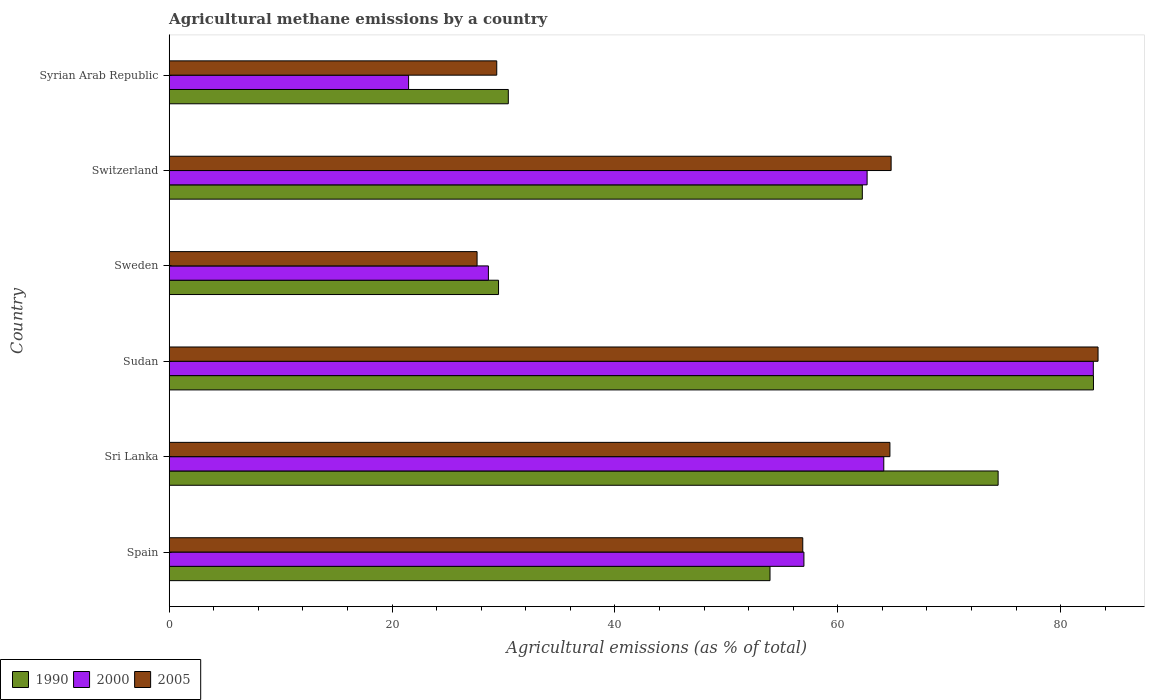How many different coloured bars are there?
Ensure brevity in your answer.  3. How many groups of bars are there?
Provide a short and direct response. 6. Are the number of bars on each tick of the Y-axis equal?
Offer a terse response. Yes. How many bars are there on the 3rd tick from the bottom?
Your answer should be compact. 3. What is the label of the 1st group of bars from the top?
Your response must be concise. Syrian Arab Republic. What is the amount of agricultural methane emitted in 2000 in Sweden?
Keep it short and to the point. 28.65. Across all countries, what is the maximum amount of agricultural methane emitted in 1990?
Your answer should be very brief. 82.95. Across all countries, what is the minimum amount of agricultural methane emitted in 1990?
Your answer should be very brief. 29.55. In which country was the amount of agricultural methane emitted in 2005 maximum?
Provide a short and direct response. Sudan. In which country was the amount of agricultural methane emitted in 2000 minimum?
Offer a very short reply. Syrian Arab Republic. What is the total amount of agricultural methane emitted in 1990 in the graph?
Your answer should be compact. 333.45. What is the difference between the amount of agricultural methane emitted in 2005 in Switzerland and that in Syrian Arab Republic?
Your answer should be compact. 35.39. What is the difference between the amount of agricultural methane emitted in 1990 in Sri Lanka and the amount of agricultural methane emitted in 2005 in Sudan?
Your answer should be compact. -8.97. What is the average amount of agricultural methane emitted in 1990 per country?
Offer a very short reply. 55.57. What is the difference between the amount of agricultural methane emitted in 2005 and amount of agricultural methane emitted in 2000 in Sweden?
Your answer should be very brief. -1.02. In how many countries, is the amount of agricultural methane emitted in 2000 greater than 16 %?
Your answer should be compact. 6. What is the ratio of the amount of agricultural methane emitted in 2000 in Spain to that in Sudan?
Offer a terse response. 0.69. Is the difference between the amount of agricultural methane emitted in 2005 in Sudan and Sweden greater than the difference between the amount of agricultural methane emitted in 2000 in Sudan and Sweden?
Your answer should be compact. Yes. What is the difference between the highest and the second highest amount of agricultural methane emitted in 1990?
Your answer should be compact. 8.56. What is the difference between the highest and the lowest amount of agricultural methane emitted in 2005?
Make the answer very short. 55.73. In how many countries, is the amount of agricultural methane emitted in 2000 greater than the average amount of agricultural methane emitted in 2000 taken over all countries?
Offer a very short reply. 4. Is the sum of the amount of agricultural methane emitted in 2000 in Switzerland and Syrian Arab Republic greater than the maximum amount of agricultural methane emitted in 2005 across all countries?
Provide a short and direct response. Yes. What does the 3rd bar from the top in Sudan represents?
Make the answer very short. 1990. What does the 1st bar from the bottom in Switzerland represents?
Provide a short and direct response. 1990. What is the difference between two consecutive major ticks on the X-axis?
Your answer should be very brief. 20. Does the graph contain grids?
Offer a terse response. No. How many legend labels are there?
Your response must be concise. 3. How are the legend labels stacked?
Your response must be concise. Horizontal. What is the title of the graph?
Make the answer very short. Agricultural methane emissions by a country. Does "1976" appear as one of the legend labels in the graph?
Offer a terse response. No. What is the label or title of the X-axis?
Make the answer very short. Agricultural emissions (as % of total). What is the label or title of the Y-axis?
Ensure brevity in your answer.  Country. What is the Agricultural emissions (as % of total) of 1990 in Spain?
Your answer should be very brief. 53.92. What is the Agricultural emissions (as % of total) in 2000 in Spain?
Give a very brief answer. 56.96. What is the Agricultural emissions (as % of total) of 2005 in Spain?
Offer a very short reply. 56.86. What is the Agricultural emissions (as % of total) of 1990 in Sri Lanka?
Offer a very short reply. 74.39. What is the Agricultural emissions (as % of total) of 2000 in Sri Lanka?
Your response must be concise. 64.13. What is the Agricultural emissions (as % of total) in 2005 in Sri Lanka?
Make the answer very short. 64.68. What is the Agricultural emissions (as % of total) in 1990 in Sudan?
Make the answer very short. 82.95. What is the Agricultural emissions (as % of total) in 2000 in Sudan?
Provide a short and direct response. 82.93. What is the Agricultural emissions (as % of total) in 2005 in Sudan?
Offer a terse response. 83.36. What is the Agricultural emissions (as % of total) of 1990 in Sweden?
Offer a very short reply. 29.55. What is the Agricultural emissions (as % of total) of 2000 in Sweden?
Provide a short and direct response. 28.65. What is the Agricultural emissions (as % of total) of 2005 in Sweden?
Provide a short and direct response. 27.63. What is the Agricultural emissions (as % of total) of 1990 in Switzerland?
Your answer should be compact. 62.2. What is the Agricultural emissions (as % of total) of 2000 in Switzerland?
Your answer should be very brief. 62.63. What is the Agricultural emissions (as % of total) of 2005 in Switzerland?
Your response must be concise. 64.79. What is the Agricultural emissions (as % of total) of 1990 in Syrian Arab Republic?
Keep it short and to the point. 30.43. What is the Agricultural emissions (as % of total) of 2000 in Syrian Arab Republic?
Give a very brief answer. 21.48. What is the Agricultural emissions (as % of total) in 2005 in Syrian Arab Republic?
Provide a succinct answer. 29.39. Across all countries, what is the maximum Agricultural emissions (as % of total) in 1990?
Make the answer very short. 82.95. Across all countries, what is the maximum Agricultural emissions (as % of total) of 2000?
Your answer should be compact. 82.93. Across all countries, what is the maximum Agricultural emissions (as % of total) in 2005?
Offer a very short reply. 83.36. Across all countries, what is the minimum Agricultural emissions (as % of total) in 1990?
Ensure brevity in your answer.  29.55. Across all countries, what is the minimum Agricultural emissions (as % of total) in 2000?
Provide a succinct answer. 21.48. Across all countries, what is the minimum Agricultural emissions (as % of total) in 2005?
Your answer should be compact. 27.63. What is the total Agricultural emissions (as % of total) in 1990 in the graph?
Provide a short and direct response. 333.45. What is the total Agricultural emissions (as % of total) of 2000 in the graph?
Your answer should be compact. 316.79. What is the total Agricultural emissions (as % of total) of 2005 in the graph?
Keep it short and to the point. 326.71. What is the difference between the Agricultural emissions (as % of total) in 1990 in Spain and that in Sri Lanka?
Make the answer very short. -20.47. What is the difference between the Agricultural emissions (as % of total) of 2000 in Spain and that in Sri Lanka?
Keep it short and to the point. -7.17. What is the difference between the Agricultural emissions (as % of total) of 2005 in Spain and that in Sri Lanka?
Offer a terse response. -7.82. What is the difference between the Agricultural emissions (as % of total) in 1990 in Spain and that in Sudan?
Give a very brief answer. -29.03. What is the difference between the Agricultural emissions (as % of total) in 2000 in Spain and that in Sudan?
Ensure brevity in your answer.  -25.97. What is the difference between the Agricultural emissions (as % of total) of 2005 in Spain and that in Sudan?
Ensure brevity in your answer.  -26.5. What is the difference between the Agricultural emissions (as % of total) of 1990 in Spain and that in Sweden?
Provide a succinct answer. 24.36. What is the difference between the Agricultural emissions (as % of total) in 2000 in Spain and that in Sweden?
Provide a succinct answer. 28.32. What is the difference between the Agricultural emissions (as % of total) of 2005 in Spain and that in Sweden?
Offer a very short reply. 29.23. What is the difference between the Agricultural emissions (as % of total) of 1990 in Spain and that in Switzerland?
Your answer should be compact. -8.29. What is the difference between the Agricultural emissions (as % of total) of 2000 in Spain and that in Switzerland?
Offer a very short reply. -5.67. What is the difference between the Agricultural emissions (as % of total) of 2005 in Spain and that in Switzerland?
Keep it short and to the point. -7.93. What is the difference between the Agricultural emissions (as % of total) of 1990 in Spain and that in Syrian Arab Republic?
Your answer should be compact. 23.49. What is the difference between the Agricultural emissions (as % of total) in 2000 in Spain and that in Syrian Arab Republic?
Offer a very short reply. 35.48. What is the difference between the Agricultural emissions (as % of total) of 2005 in Spain and that in Syrian Arab Republic?
Offer a very short reply. 27.46. What is the difference between the Agricultural emissions (as % of total) of 1990 in Sri Lanka and that in Sudan?
Ensure brevity in your answer.  -8.56. What is the difference between the Agricultural emissions (as % of total) of 2000 in Sri Lanka and that in Sudan?
Provide a succinct answer. -18.8. What is the difference between the Agricultural emissions (as % of total) of 2005 in Sri Lanka and that in Sudan?
Keep it short and to the point. -18.68. What is the difference between the Agricultural emissions (as % of total) of 1990 in Sri Lanka and that in Sweden?
Ensure brevity in your answer.  44.84. What is the difference between the Agricultural emissions (as % of total) in 2000 in Sri Lanka and that in Sweden?
Your response must be concise. 35.48. What is the difference between the Agricultural emissions (as % of total) in 2005 in Sri Lanka and that in Sweden?
Provide a succinct answer. 37.05. What is the difference between the Agricultural emissions (as % of total) of 1990 in Sri Lanka and that in Switzerland?
Provide a short and direct response. 12.19. What is the difference between the Agricultural emissions (as % of total) of 2000 in Sri Lanka and that in Switzerland?
Make the answer very short. 1.5. What is the difference between the Agricultural emissions (as % of total) in 2005 in Sri Lanka and that in Switzerland?
Provide a succinct answer. -0.11. What is the difference between the Agricultural emissions (as % of total) of 1990 in Sri Lanka and that in Syrian Arab Republic?
Provide a short and direct response. 43.96. What is the difference between the Agricultural emissions (as % of total) in 2000 in Sri Lanka and that in Syrian Arab Republic?
Your answer should be compact. 42.65. What is the difference between the Agricultural emissions (as % of total) in 2005 in Sri Lanka and that in Syrian Arab Republic?
Provide a short and direct response. 35.28. What is the difference between the Agricultural emissions (as % of total) in 1990 in Sudan and that in Sweden?
Give a very brief answer. 53.39. What is the difference between the Agricultural emissions (as % of total) in 2000 in Sudan and that in Sweden?
Give a very brief answer. 54.29. What is the difference between the Agricultural emissions (as % of total) of 2005 in Sudan and that in Sweden?
Offer a very short reply. 55.73. What is the difference between the Agricultural emissions (as % of total) in 1990 in Sudan and that in Switzerland?
Provide a succinct answer. 20.74. What is the difference between the Agricultural emissions (as % of total) of 2000 in Sudan and that in Switzerland?
Offer a very short reply. 20.3. What is the difference between the Agricultural emissions (as % of total) in 2005 in Sudan and that in Switzerland?
Your response must be concise. 18.57. What is the difference between the Agricultural emissions (as % of total) of 1990 in Sudan and that in Syrian Arab Republic?
Your response must be concise. 52.51. What is the difference between the Agricultural emissions (as % of total) in 2000 in Sudan and that in Syrian Arab Republic?
Provide a succinct answer. 61.45. What is the difference between the Agricultural emissions (as % of total) of 2005 in Sudan and that in Syrian Arab Republic?
Provide a succinct answer. 53.96. What is the difference between the Agricultural emissions (as % of total) of 1990 in Sweden and that in Switzerland?
Offer a terse response. -32.65. What is the difference between the Agricultural emissions (as % of total) in 2000 in Sweden and that in Switzerland?
Give a very brief answer. -33.99. What is the difference between the Agricultural emissions (as % of total) in 2005 in Sweden and that in Switzerland?
Your answer should be compact. -37.16. What is the difference between the Agricultural emissions (as % of total) in 1990 in Sweden and that in Syrian Arab Republic?
Your response must be concise. -0.88. What is the difference between the Agricultural emissions (as % of total) of 2000 in Sweden and that in Syrian Arab Republic?
Offer a terse response. 7.16. What is the difference between the Agricultural emissions (as % of total) of 2005 in Sweden and that in Syrian Arab Republic?
Your answer should be compact. -1.77. What is the difference between the Agricultural emissions (as % of total) in 1990 in Switzerland and that in Syrian Arab Republic?
Your answer should be compact. 31.77. What is the difference between the Agricultural emissions (as % of total) of 2000 in Switzerland and that in Syrian Arab Republic?
Offer a terse response. 41.15. What is the difference between the Agricultural emissions (as % of total) of 2005 in Switzerland and that in Syrian Arab Republic?
Offer a terse response. 35.39. What is the difference between the Agricultural emissions (as % of total) of 1990 in Spain and the Agricultural emissions (as % of total) of 2000 in Sri Lanka?
Your response must be concise. -10.21. What is the difference between the Agricultural emissions (as % of total) in 1990 in Spain and the Agricultural emissions (as % of total) in 2005 in Sri Lanka?
Offer a very short reply. -10.76. What is the difference between the Agricultural emissions (as % of total) of 2000 in Spain and the Agricultural emissions (as % of total) of 2005 in Sri Lanka?
Provide a succinct answer. -7.72. What is the difference between the Agricultural emissions (as % of total) of 1990 in Spain and the Agricultural emissions (as % of total) of 2000 in Sudan?
Keep it short and to the point. -29.01. What is the difference between the Agricultural emissions (as % of total) in 1990 in Spain and the Agricultural emissions (as % of total) in 2005 in Sudan?
Keep it short and to the point. -29.44. What is the difference between the Agricultural emissions (as % of total) of 2000 in Spain and the Agricultural emissions (as % of total) of 2005 in Sudan?
Ensure brevity in your answer.  -26.4. What is the difference between the Agricultural emissions (as % of total) of 1990 in Spain and the Agricultural emissions (as % of total) of 2000 in Sweden?
Your response must be concise. 25.27. What is the difference between the Agricultural emissions (as % of total) of 1990 in Spain and the Agricultural emissions (as % of total) of 2005 in Sweden?
Offer a terse response. 26.29. What is the difference between the Agricultural emissions (as % of total) in 2000 in Spain and the Agricultural emissions (as % of total) in 2005 in Sweden?
Offer a very short reply. 29.33. What is the difference between the Agricultural emissions (as % of total) of 1990 in Spain and the Agricultural emissions (as % of total) of 2000 in Switzerland?
Your answer should be very brief. -8.71. What is the difference between the Agricultural emissions (as % of total) of 1990 in Spain and the Agricultural emissions (as % of total) of 2005 in Switzerland?
Offer a terse response. -10.87. What is the difference between the Agricultural emissions (as % of total) in 2000 in Spain and the Agricultural emissions (as % of total) in 2005 in Switzerland?
Your response must be concise. -7.83. What is the difference between the Agricultural emissions (as % of total) in 1990 in Spain and the Agricultural emissions (as % of total) in 2000 in Syrian Arab Republic?
Give a very brief answer. 32.44. What is the difference between the Agricultural emissions (as % of total) in 1990 in Spain and the Agricultural emissions (as % of total) in 2005 in Syrian Arab Republic?
Your response must be concise. 24.52. What is the difference between the Agricultural emissions (as % of total) in 2000 in Spain and the Agricultural emissions (as % of total) in 2005 in Syrian Arab Republic?
Your answer should be very brief. 27.57. What is the difference between the Agricultural emissions (as % of total) of 1990 in Sri Lanka and the Agricultural emissions (as % of total) of 2000 in Sudan?
Give a very brief answer. -8.54. What is the difference between the Agricultural emissions (as % of total) in 1990 in Sri Lanka and the Agricultural emissions (as % of total) in 2005 in Sudan?
Your response must be concise. -8.97. What is the difference between the Agricultural emissions (as % of total) of 2000 in Sri Lanka and the Agricultural emissions (as % of total) of 2005 in Sudan?
Offer a very short reply. -19.23. What is the difference between the Agricultural emissions (as % of total) in 1990 in Sri Lanka and the Agricultural emissions (as % of total) in 2000 in Sweden?
Your answer should be compact. 45.74. What is the difference between the Agricultural emissions (as % of total) of 1990 in Sri Lanka and the Agricultural emissions (as % of total) of 2005 in Sweden?
Offer a terse response. 46.76. What is the difference between the Agricultural emissions (as % of total) in 2000 in Sri Lanka and the Agricultural emissions (as % of total) in 2005 in Sweden?
Offer a very short reply. 36.5. What is the difference between the Agricultural emissions (as % of total) in 1990 in Sri Lanka and the Agricultural emissions (as % of total) in 2000 in Switzerland?
Keep it short and to the point. 11.76. What is the difference between the Agricultural emissions (as % of total) of 1990 in Sri Lanka and the Agricultural emissions (as % of total) of 2005 in Switzerland?
Make the answer very short. 9.6. What is the difference between the Agricultural emissions (as % of total) in 2000 in Sri Lanka and the Agricultural emissions (as % of total) in 2005 in Switzerland?
Keep it short and to the point. -0.66. What is the difference between the Agricultural emissions (as % of total) in 1990 in Sri Lanka and the Agricultural emissions (as % of total) in 2000 in Syrian Arab Republic?
Ensure brevity in your answer.  52.91. What is the difference between the Agricultural emissions (as % of total) in 1990 in Sri Lanka and the Agricultural emissions (as % of total) in 2005 in Syrian Arab Republic?
Provide a short and direct response. 45. What is the difference between the Agricultural emissions (as % of total) in 2000 in Sri Lanka and the Agricultural emissions (as % of total) in 2005 in Syrian Arab Republic?
Your answer should be compact. 34.73. What is the difference between the Agricultural emissions (as % of total) in 1990 in Sudan and the Agricultural emissions (as % of total) in 2000 in Sweden?
Offer a terse response. 54.3. What is the difference between the Agricultural emissions (as % of total) of 1990 in Sudan and the Agricultural emissions (as % of total) of 2005 in Sweden?
Make the answer very short. 55.32. What is the difference between the Agricultural emissions (as % of total) in 2000 in Sudan and the Agricultural emissions (as % of total) in 2005 in Sweden?
Offer a terse response. 55.3. What is the difference between the Agricultural emissions (as % of total) in 1990 in Sudan and the Agricultural emissions (as % of total) in 2000 in Switzerland?
Make the answer very short. 20.31. What is the difference between the Agricultural emissions (as % of total) of 1990 in Sudan and the Agricultural emissions (as % of total) of 2005 in Switzerland?
Ensure brevity in your answer.  18.16. What is the difference between the Agricultural emissions (as % of total) in 2000 in Sudan and the Agricultural emissions (as % of total) in 2005 in Switzerland?
Make the answer very short. 18.14. What is the difference between the Agricultural emissions (as % of total) of 1990 in Sudan and the Agricultural emissions (as % of total) of 2000 in Syrian Arab Republic?
Offer a terse response. 61.46. What is the difference between the Agricultural emissions (as % of total) in 1990 in Sudan and the Agricultural emissions (as % of total) in 2005 in Syrian Arab Republic?
Offer a very short reply. 53.55. What is the difference between the Agricultural emissions (as % of total) of 2000 in Sudan and the Agricultural emissions (as % of total) of 2005 in Syrian Arab Republic?
Your answer should be very brief. 53.54. What is the difference between the Agricultural emissions (as % of total) in 1990 in Sweden and the Agricultural emissions (as % of total) in 2000 in Switzerland?
Keep it short and to the point. -33.08. What is the difference between the Agricultural emissions (as % of total) in 1990 in Sweden and the Agricultural emissions (as % of total) in 2005 in Switzerland?
Offer a very short reply. -35.23. What is the difference between the Agricultural emissions (as % of total) of 2000 in Sweden and the Agricultural emissions (as % of total) of 2005 in Switzerland?
Offer a terse response. -36.14. What is the difference between the Agricultural emissions (as % of total) in 1990 in Sweden and the Agricultural emissions (as % of total) in 2000 in Syrian Arab Republic?
Offer a terse response. 8.07. What is the difference between the Agricultural emissions (as % of total) in 1990 in Sweden and the Agricultural emissions (as % of total) in 2005 in Syrian Arab Republic?
Offer a very short reply. 0.16. What is the difference between the Agricultural emissions (as % of total) in 2000 in Sweden and the Agricultural emissions (as % of total) in 2005 in Syrian Arab Republic?
Your response must be concise. -0.75. What is the difference between the Agricultural emissions (as % of total) in 1990 in Switzerland and the Agricultural emissions (as % of total) in 2000 in Syrian Arab Republic?
Make the answer very short. 40.72. What is the difference between the Agricultural emissions (as % of total) of 1990 in Switzerland and the Agricultural emissions (as % of total) of 2005 in Syrian Arab Republic?
Offer a terse response. 32.81. What is the difference between the Agricultural emissions (as % of total) of 2000 in Switzerland and the Agricultural emissions (as % of total) of 2005 in Syrian Arab Republic?
Offer a terse response. 33.24. What is the average Agricultural emissions (as % of total) in 1990 per country?
Keep it short and to the point. 55.57. What is the average Agricultural emissions (as % of total) of 2000 per country?
Your answer should be very brief. 52.8. What is the average Agricultural emissions (as % of total) in 2005 per country?
Offer a terse response. 54.45. What is the difference between the Agricultural emissions (as % of total) of 1990 and Agricultural emissions (as % of total) of 2000 in Spain?
Provide a short and direct response. -3.04. What is the difference between the Agricultural emissions (as % of total) of 1990 and Agricultural emissions (as % of total) of 2005 in Spain?
Offer a terse response. -2.94. What is the difference between the Agricultural emissions (as % of total) in 2000 and Agricultural emissions (as % of total) in 2005 in Spain?
Provide a succinct answer. 0.1. What is the difference between the Agricultural emissions (as % of total) in 1990 and Agricultural emissions (as % of total) in 2000 in Sri Lanka?
Ensure brevity in your answer.  10.26. What is the difference between the Agricultural emissions (as % of total) of 1990 and Agricultural emissions (as % of total) of 2005 in Sri Lanka?
Keep it short and to the point. 9.71. What is the difference between the Agricultural emissions (as % of total) of 2000 and Agricultural emissions (as % of total) of 2005 in Sri Lanka?
Offer a very short reply. -0.55. What is the difference between the Agricultural emissions (as % of total) of 1990 and Agricultural emissions (as % of total) of 2000 in Sudan?
Your response must be concise. 0.01. What is the difference between the Agricultural emissions (as % of total) of 1990 and Agricultural emissions (as % of total) of 2005 in Sudan?
Keep it short and to the point. -0.41. What is the difference between the Agricultural emissions (as % of total) in 2000 and Agricultural emissions (as % of total) in 2005 in Sudan?
Provide a succinct answer. -0.43. What is the difference between the Agricultural emissions (as % of total) in 1990 and Agricultural emissions (as % of total) in 2000 in Sweden?
Keep it short and to the point. 0.91. What is the difference between the Agricultural emissions (as % of total) of 1990 and Agricultural emissions (as % of total) of 2005 in Sweden?
Your answer should be very brief. 1.93. What is the difference between the Agricultural emissions (as % of total) in 2000 and Agricultural emissions (as % of total) in 2005 in Sweden?
Your response must be concise. 1.02. What is the difference between the Agricultural emissions (as % of total) in 1990 and Agricultural emissions (as % of total) in 2000 in Switzerland?
Ensure brevity in your answer.  -0.43. What is the difference between the Agricultural emissions (as % of total) in 1990 and Agricultural emissions (as % of total) in 2005 in Switzerland?
Make the answer very short. -2.58. What is the difference between the Agricultural emissions (as % of total) in 2000 and Agricultural emissions (as % of total) in 2005 in Switzerland?
Provide a succinct answer. -2.15. What is the difference between the Agricultural emissions (as % of total) of 1990 and Agricultural emissions (as % of total) of 2000 in Syrian Arab Republic?
Offer a terse response. 8.95. What is the difference between the Agricultural emissions (as % of total) of 1990 and Agricultural emissions (as % of total) of 2005 in Syrian Arab Republic?
Ensure brevity in your answer.  1.04. What is the difference between the Agricultural emissions (as % of total) of 2000 and Agricultural emissions (as % of total) of 2005 in Syrian Arab Republic?
Offer a terse response. -7.91. What is the ratio of the Agricultural emissions (as % of total) in 1990 in Spain to that in Sri Lanka?
Your answer should be very brief. 0.72. What is the ratio of the Agricultural emissions (as % of total) of 2000 in Spain to that in Sri Lanka?
Your response must be concise. 0.89. What is the ratio of the Agricultural emissions (as % of total) in 2005 in Spain to that in Sri Lanka?
Ensure brevity in your answer.  0.88. What is the ratio of the Agricultural emissions (as % of total) in 1990 in Spain to that in Sudan?
Ensure brevity in your answer.  0.65. What is the ratio of the Agricultural emissions (as % of total) in 2000 in Spain to that in Sudan?
Provide a short and direct response. 0.69. What is the ratio of the Agricultural emissions (as % of total) of 2005 in Spain to that in Sudan?
Provide a short and direct response. 0.68. What is the ratio of the Agricultural emissions (as % of total) in 1990 in Spain to that in Sweden?
Your response must be concise. 1.82. What is the ratio of the Agricultural emissions (as % of total) of 2000 in Spain to that in Sweden?
Your answer should be very brief. 1.99. What is the ratio of the Agricultural emissions (as % of total) of 2005 in Spain to that in Sweden?
Make the answer very short. 2.06. What is the ratio of the Agricultural emissions (as % of total) of 1990 in Spain to that in Switzerland?
Provide a succinct answer. 0.87. What is the ratio of the Agricultural emissions (as % of total) in 2000 in Spain to that in Switzerland?
Your answer should be very brief. 0.91. What is the ratio of the Agricultural emissions (as % of total) in 2005 in Spain to that in Switzerland?
Your answer should be very brief. 0.88. What is the ratio of the Agricultural emissions (as % of total) in 1990 in Spain to that in Syrian Arab Republic?
Offer a very short reply. 1.77. What is the ratio of the Agricultural emissions (as % of total) of 2000 in Spain to that in Syrian Arab Republic?
Provide a short and direct response. 2.65. What is the ratio of the Agricultural emissions (as % of total) in 2005 in Spain to that in Syrian Arab Republic?
Offer a very short reply. 1.93. What is the ratio of the Agricultural emissions (as % of total) in 1990 in Sri Lanka to that in Sudan?
Provide a succinct answer. 0.9. What is the ratio of the Agricultural emissions (as % of total) in 2000 in Sri Lanka to that in Sudan?
Keep it short and to the point. 0.77. What is the ratio of the Agricultural emissions (as % of total) in 2005 in Sri Lanka to that in Sudan?
Provide a succinct answer. 0.78. What is the ratio of the Agricultural emissions (as % of total) of 1990 in Sri Lanka to that in Sweden?
Provide a succinct answer. 2.52. What is the ratio of the Agricultural emissions (as % of total) of 2000 in Sri Lanka to that in Sweden?
Give a very brief answer. 2.24. What is the ratio of the Agricultural emissions (as % of total) in 2005 in Sri Lanka to that in Sweden?
Provide a succinct answer. 2.34. What is the ratio of the Agricultural emissions (as % of total) of 1990 in Sri Lanka to that in Switzerland?
Offer a very short reply. 1.2. What is the ratio of the Agricultural emissions (as % of total) in 2000 in Sri Lanka to that in Switzerland?
Make the answer very short. 1.02. What is the ratio of the Agricultural emissions (as % of total) of 1990 in Sri Lanka to that in Syrian Arab Republic?
Keep it short and to the point. 2.44. What is the ratio of the Agricultural emissions (as % of total) in 2000 in Sri Lanka to that in Syrian Arab Republic?
Give a very brief answer. 2.98. What is the ratio of the Agricultural emissions (as % of total) in 2005 in Sri Lanka to that in Syrian Arab Republic?
Your response must be concise. 2.2. What is the ratio of the Agricultural emissions (as % of total) in 1990 in Sudan to that in Sweden?
Your answer should be very brief. 2.81. What is the ratio of the Agricultural emissions (as % of total) of 2000 in Sudan to that in Sweden?
Keep it short and to the point. 2.9. What is the ratio of the Agricultural emissions (as % of total) in 2005 in Sudan to that in Sweden?
Give a very brief answer. 3.02. What is the ratio of the Agricultural emissions (as % of total) of 1990 in Sudan to that in Switzerland?
Make the answer very short. 1.33. What is the ratio of the Agricultural emissions (as % of total) of 2000 in Sudan to that in Switzerland?
Your answer should be compact. 1.32. What is the ratio of the Agricultural emissions (as % of total) of 2005 in Sudan to that in Switzerland?
Provide a short and direct response. 1.29. What is the ratio of the Agricultural emissions (as % of total) in 1990 in Sudan to that in Syrian Arab Republic?
Ensure brevity in your answer.  2.73. What is the ratio of the Agricultural emissions (as % of total) in 2000 in Sudan to that in Syrian Arab Republic?
Keep it short and to the point. 3.86. What is the ratio of the Agricultural emissions (as % of total) of 2005 in Sudan to that in Syrian Arab Republic?
Ensure brevity in your answer.  2.84. What is the ratio of the Agricultural emissions (as % of total) in 1990 in Sweden to that in Switzerland?
Make the answer very short. 0.48. What is the ratio of the Agricultural emissions (as % of total) of 2000 in Sweden to that in Switzerland?
Your response must be concise. 0.46. What is the ratio of the Agricultural emissions (as % of total) of 2005 in Sweden to that in Switzerland?
Your answer should be very brief. 0.43. What is the ratio of the Agricultural emissions (as % of total) of 1990 in Sweden to that in Syrian Arab Republic?
Ensure brevity in your answer.  0.97. What is the ratio of the Agricultural emissions (as % of total) in 2000 in Sweden to that in Syrian Arab Republic?
Keep it short and to the point. 1.33. What is the ratio of the Agricultural emissions (as % of total) of 2005 in Sweden to that in Syrian Arab Republic?
Your answer should be compact. 0.94. What is the ratio of the Agricultural emissions (as % of total) in 1990 in Switzerland to that in Syrian Arab Republic?
Offer a very short reply. 2.04. What is the ratio of the Agricultural emissions (as % of total) of 2000 in Switzerland to that in Syrian Arab Republic?
Make the answer very short. 2.92. What is the ratio of the Agricultural emissions (as % of total) in 2005 in Switzerland to that in Syrian Arab Republic?
Make the answer very short. 2.2. What is the difference between the highest and the second highest Agricultural emissions (as % of total) in 1990?
Your answer should be very brief. 8.56. What is the difference between the highest and the second highest Agricultural emissions (as % of total) in 2000?
Give a very brief answer. 18.8. What is the difference between the highest and the second highest Agricultural emissions (as % of total) of 2005?
Your answer should be very brief. 18.57. What is the difference between the highest and the lowest Agricultural emissions (as % of total) of 1990?
Ensure brevity in your answer.  53.39. What is the difference between the highest and the lowest Agricultural emissions (as % of total) of 2000?
Provide a succinct answer. 61.45. What is the difference between the highest and the lowest Agricultural emissions (as % of total) in 2005?
Give a very brief answer. 55.73. 